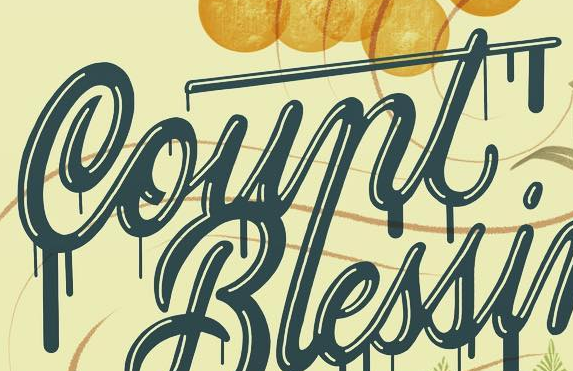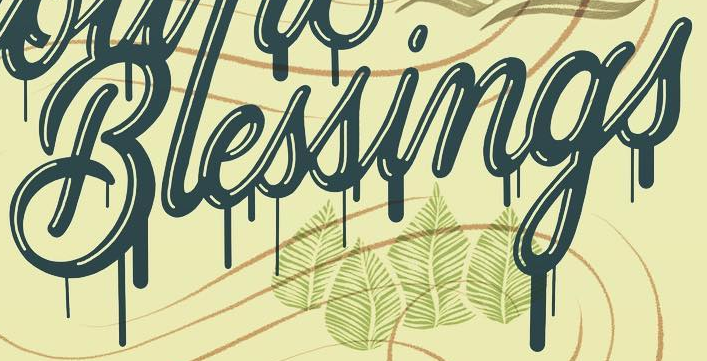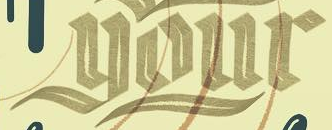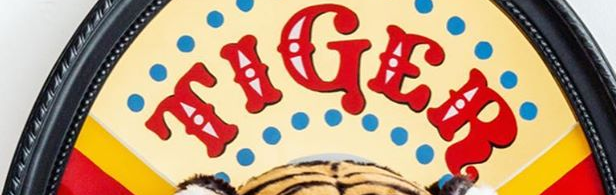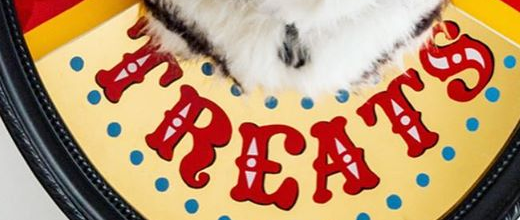Transcribe the words shown in these images in order, separated by a semicolon. Count; Blessings; your; TIGER; TREATS 